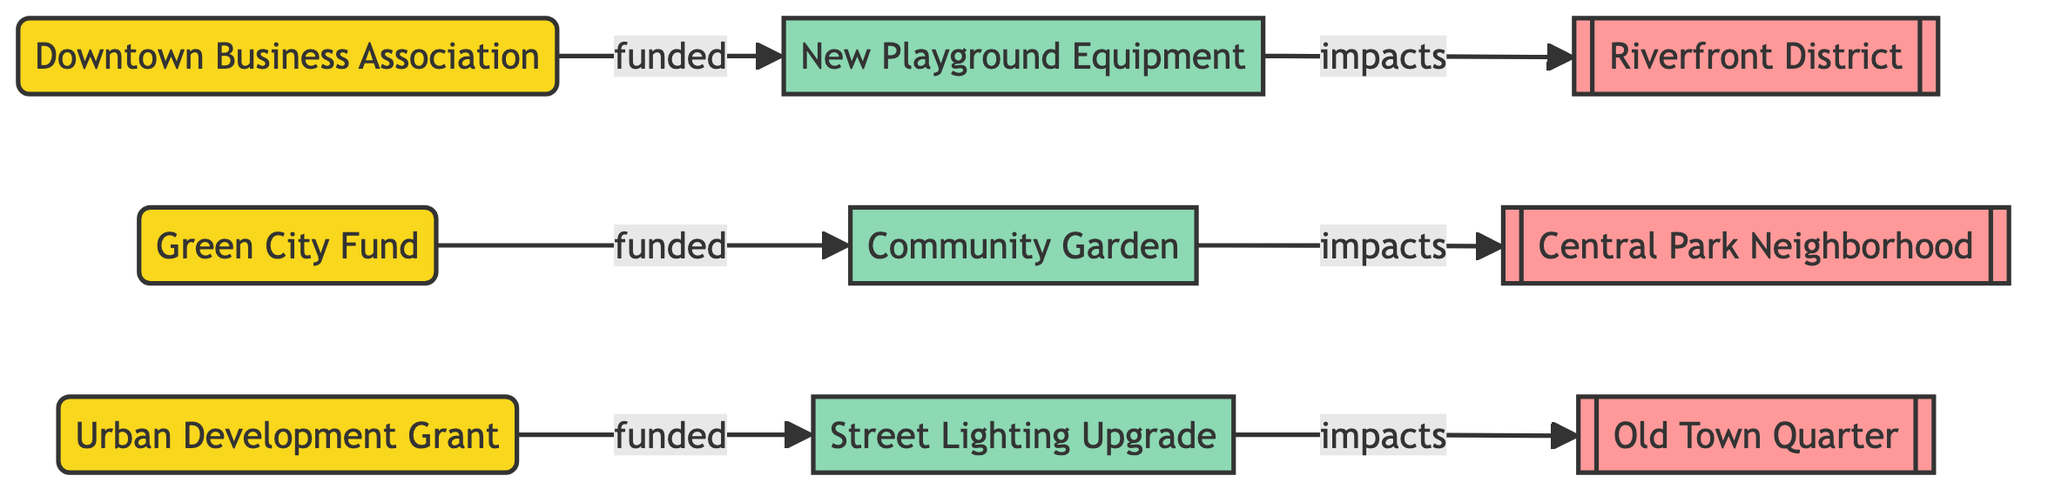What is the total number of sponsors in the diagram? By reviewing the nodes in the diagram, we can count the entries under the "sponsor" type. There are three sponsors listed: Downtown Business Association, Green City Fund, and Urban Development Grant.
Answer: 3 Which project is funded by the Downtown Business Association? By examining the edges connected to the Downtown Business Association node, we see that it is linked to the project node labeled 'New Playground Equipment' with a relationship labeled 'funded'.
Answer: New Playground Equipment What area is impacted by the Community Garden project? Looking at the edges connected to the project node 'Community Garden', we observe it is directed towards the area node labeled 'Central Park Neighborhood' with a relationship labeled 'impacts'.
Answer: Central Park Neighborhood How many projects are listed in total in the diagram? By counting the nodes of type "project", we find there are three projects: Community Garden, New Playground Equipment, and Street Lighting Upgrade.
Answer: 3 Which funding sponsor is connected to the Street Lighting Upgrade project? Analyzing the edges, we see that the 'Street Lighting Upgrade' project is funded by the 'Urban Development Grant' sponsor, as this project has a direct edge labeled 'funded' from this sponsor.
Answer: Urban Development Grant Which area is associated with the Street Lighting Upgrade project? We can see from the diagram that the project labeled 'Street Lighting Upgrade' has a connection going to the area labeled 'Old Town Quarter' with the relationship 'impacts'.
Answer: Old Town Quarter What is the relationship type between sponsors and projects? The edges connecting sponsors to projects all have the label 'funded', indicating that this is the relationship type between them.
Answer: funded What is the relationship type between projects and impacted areas? By examining the edges, we note that the relationships between projects and their corresponding impacted areas are labeled 'impacts'.
Answer: impacts Which project is funded by the Green City Fund? Looking at the edges, we see that the Green City Fund is connected to the project node labeled 'Community Garden', indicating that it is funded by this sponsor.
Answer: Community Garden 